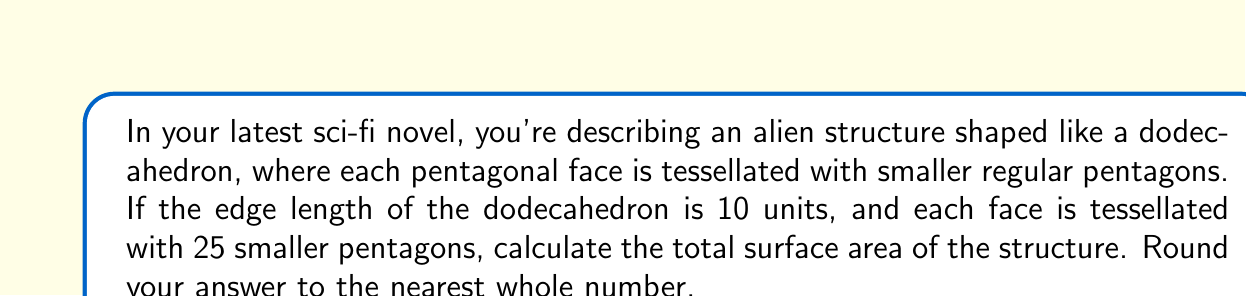Show me your answer to this math problem. Let's approach this step-by-step:

1) First, we need to calculate the area of one face of the dodecahedron:
   The area of a regular pentagon with side length $s$ is given by:
   $$A = \frac{1}{4}\sqrt{25+10\sqrt{5}}s^2$$

   We need to find $s$ for the large pentagon. In a dodecahedron, if the edge length is $a$, then the side length of each face (pentagon) is also $a$. So, $s = 10$.

   $$A = \frac{1}{4}\sqrt{25+10\sqrt{5}}(10)^2 = 25\sqrt{25+10\sqrt{5}} \approx 172.05$$

2) Now, we need to calculate the total surface area of the dodecahedron:
   $$SA_{dodecahedron} = 12 \times 25\sqrt{25+10\sqrt{5}} \approx 2064.60$$

3) However, each face is tessellated with 25 smaller pentagons. This means the actual surface area will be larger. To find out how much larger, we need to calculate the ratio of the perimeter of the tessellated surface to the original surface.

4) The perimeter of one large pentagon face is $5 \times 10 = 50$ units.
   The perimeter of each small pentagon is $\frac{50}{5} = 10$ units (since 5 small pentagons fit along each side of the large pentagon).
   
5) The total perimeter of all small pentagons on one face is:
   $25 \times 5 \times \frac{10}{5} = 250$ units

6) The ratio of the tessellated surface to the original surface is:
   $\frac{250}{50} = 5$

7) Therefore, the total surface area of the tessellated structure is:
   $$SA_{tessellated} = 5 \times 12 \times 25\sqrt{25+10\sqrt{5}} \approx 10323.00$$
Answer: 10323 square units 